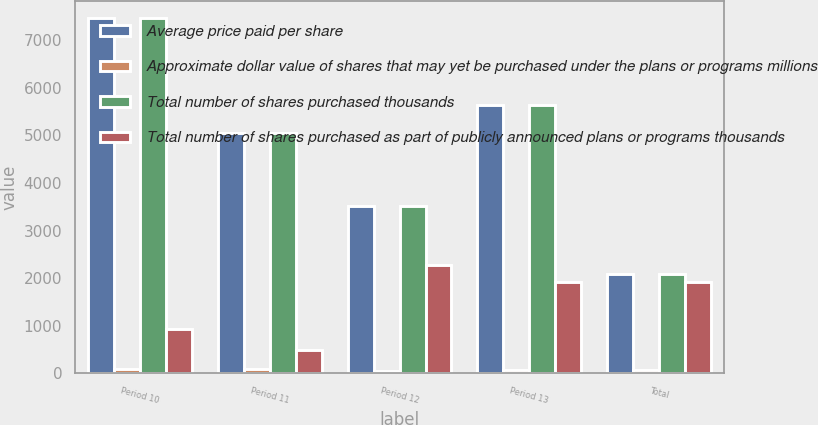Convert chart to OTSL. <chart><loc_0><loc_0><loc_500><loc_500><stacked_bar_chart><ecel><fcel>Period 10<fcel>Period 11<fcel>Period 12<fcel>Period 13<fcel>Total<nl><fcel>Average price paid per share<fcel>7458<fcel>5047<fcel>3511<fcel>5638<fcel>2095<nl><fcel>Approximate dollar value of shares that may yet be purchased under the plans or programs millions<fcel>89.15<fcel>89.15<fcel>61.38<fcel>63.84<fcel>78.06<nl><fcel>Total number of shares purchased thousands<fcel>7458<fcel>5047<fcel>3511<fcel>5638<fcel>2095<nl><fcel>Total number of shares purchased as part of publicly announced plans or programs thousands<fcel>940<fcel>490<fcel>2275<fcel>1915<fcel>1915<nl></chart> 